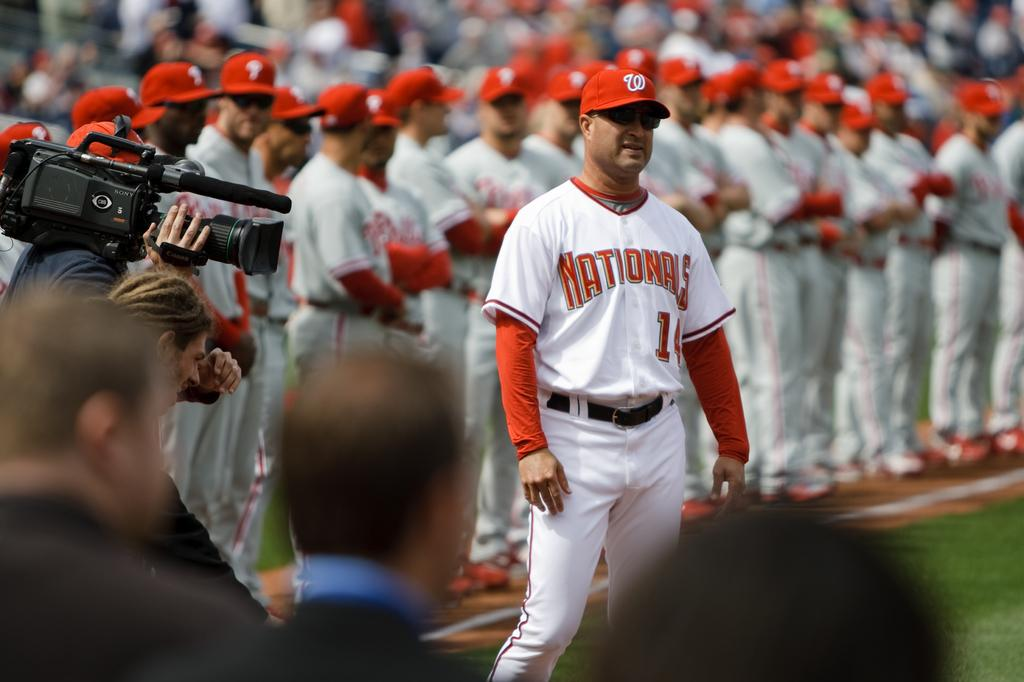<image>
Present a compact description of the photo's key features. A Nationals player wearing number 14 with his teammates behind him. 